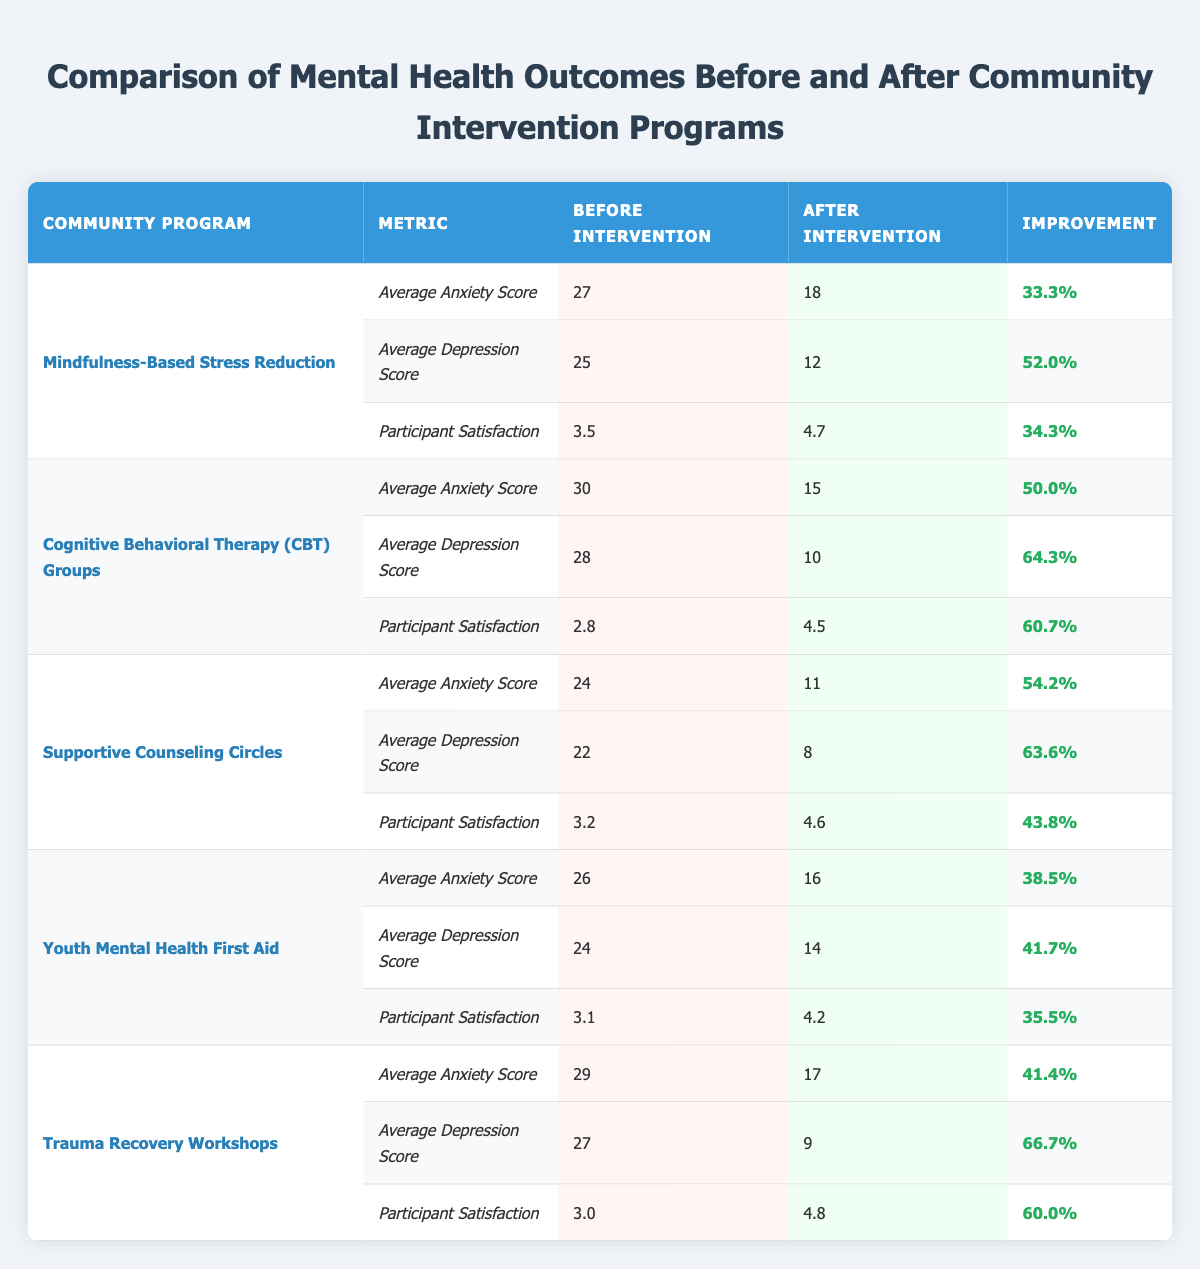What was the average anxiety score for the Supportive Counseling Circles before the intervention? The table shows that the average anxiety score for Supportive Counseling Circles before the intervention was 24.
Answer: 24 What was the participant satisfaction score for the Trauma Recovery Workshops after the intervention? According to the table, the participant satisfaction score for Trauma Recovery Workshops after the intervention was 4.8.
Answer: 4.8 Which community program had the highest average reduction in depression score? By comparing the improvements, the Cognitive Behavioral Therapy (CBT) Groups had the highest average reduction in depression score, reducing it by 64.3%.
Answer: Cognitive Behavioral Therapy (CBT) Groups What is the overall improvement in participant satisfaction across all community programs? I will calculate the total improvement. (34.3% + 60.7% + 43.8% + 35.5% + 60.0%) = 234.3%. Now divide by 5 to get the average: 234.3% / 5 = 46.86%.
Answer: 46.86% Did any programs have a participant satisfaction score below 3.0 before the intervention? Yes, the Cognitive Behavioral Therapy (CBT) Groups and Trauma Recovery Workshops had participant satisfaction scores below 3.0 before the intervention (2.8 and 3.0, respectively).
Answer: Yes Which community program showed the least improvement in average anxiety score? I need to look at the improvement percentages for average anxiety scores. Mindfulness-Based Stress Reduction showed a 33.3% improvement, which is the least compared to others.
Answer: Mindfulness-Based Stress Reduction What was the difference in average depression scores before and after the intervention for Youth Mental Health First Aid? The average depression score before was 24 and after was 14. The difference is 24 - 14 = 10.
Answer: 10 How much did the average anxiety score decrease for the Mindfulness-Based Stress Reduction program? The average anxiety score decreased from 27 to 18. The decrease is 27 - 18 = 9.
Answer: 9 Which community program had both anxiety and depression scores reduce by more than 50%? The Cognitive Behavioral Therapy (CBT) Groups and Supportive Counseling Circles had both their average anxiety and depression scores reduce by more than 50%.
Answer: Cognitive Behavioral Therapy (CBT) Groups and Supportive Counseling Circles 